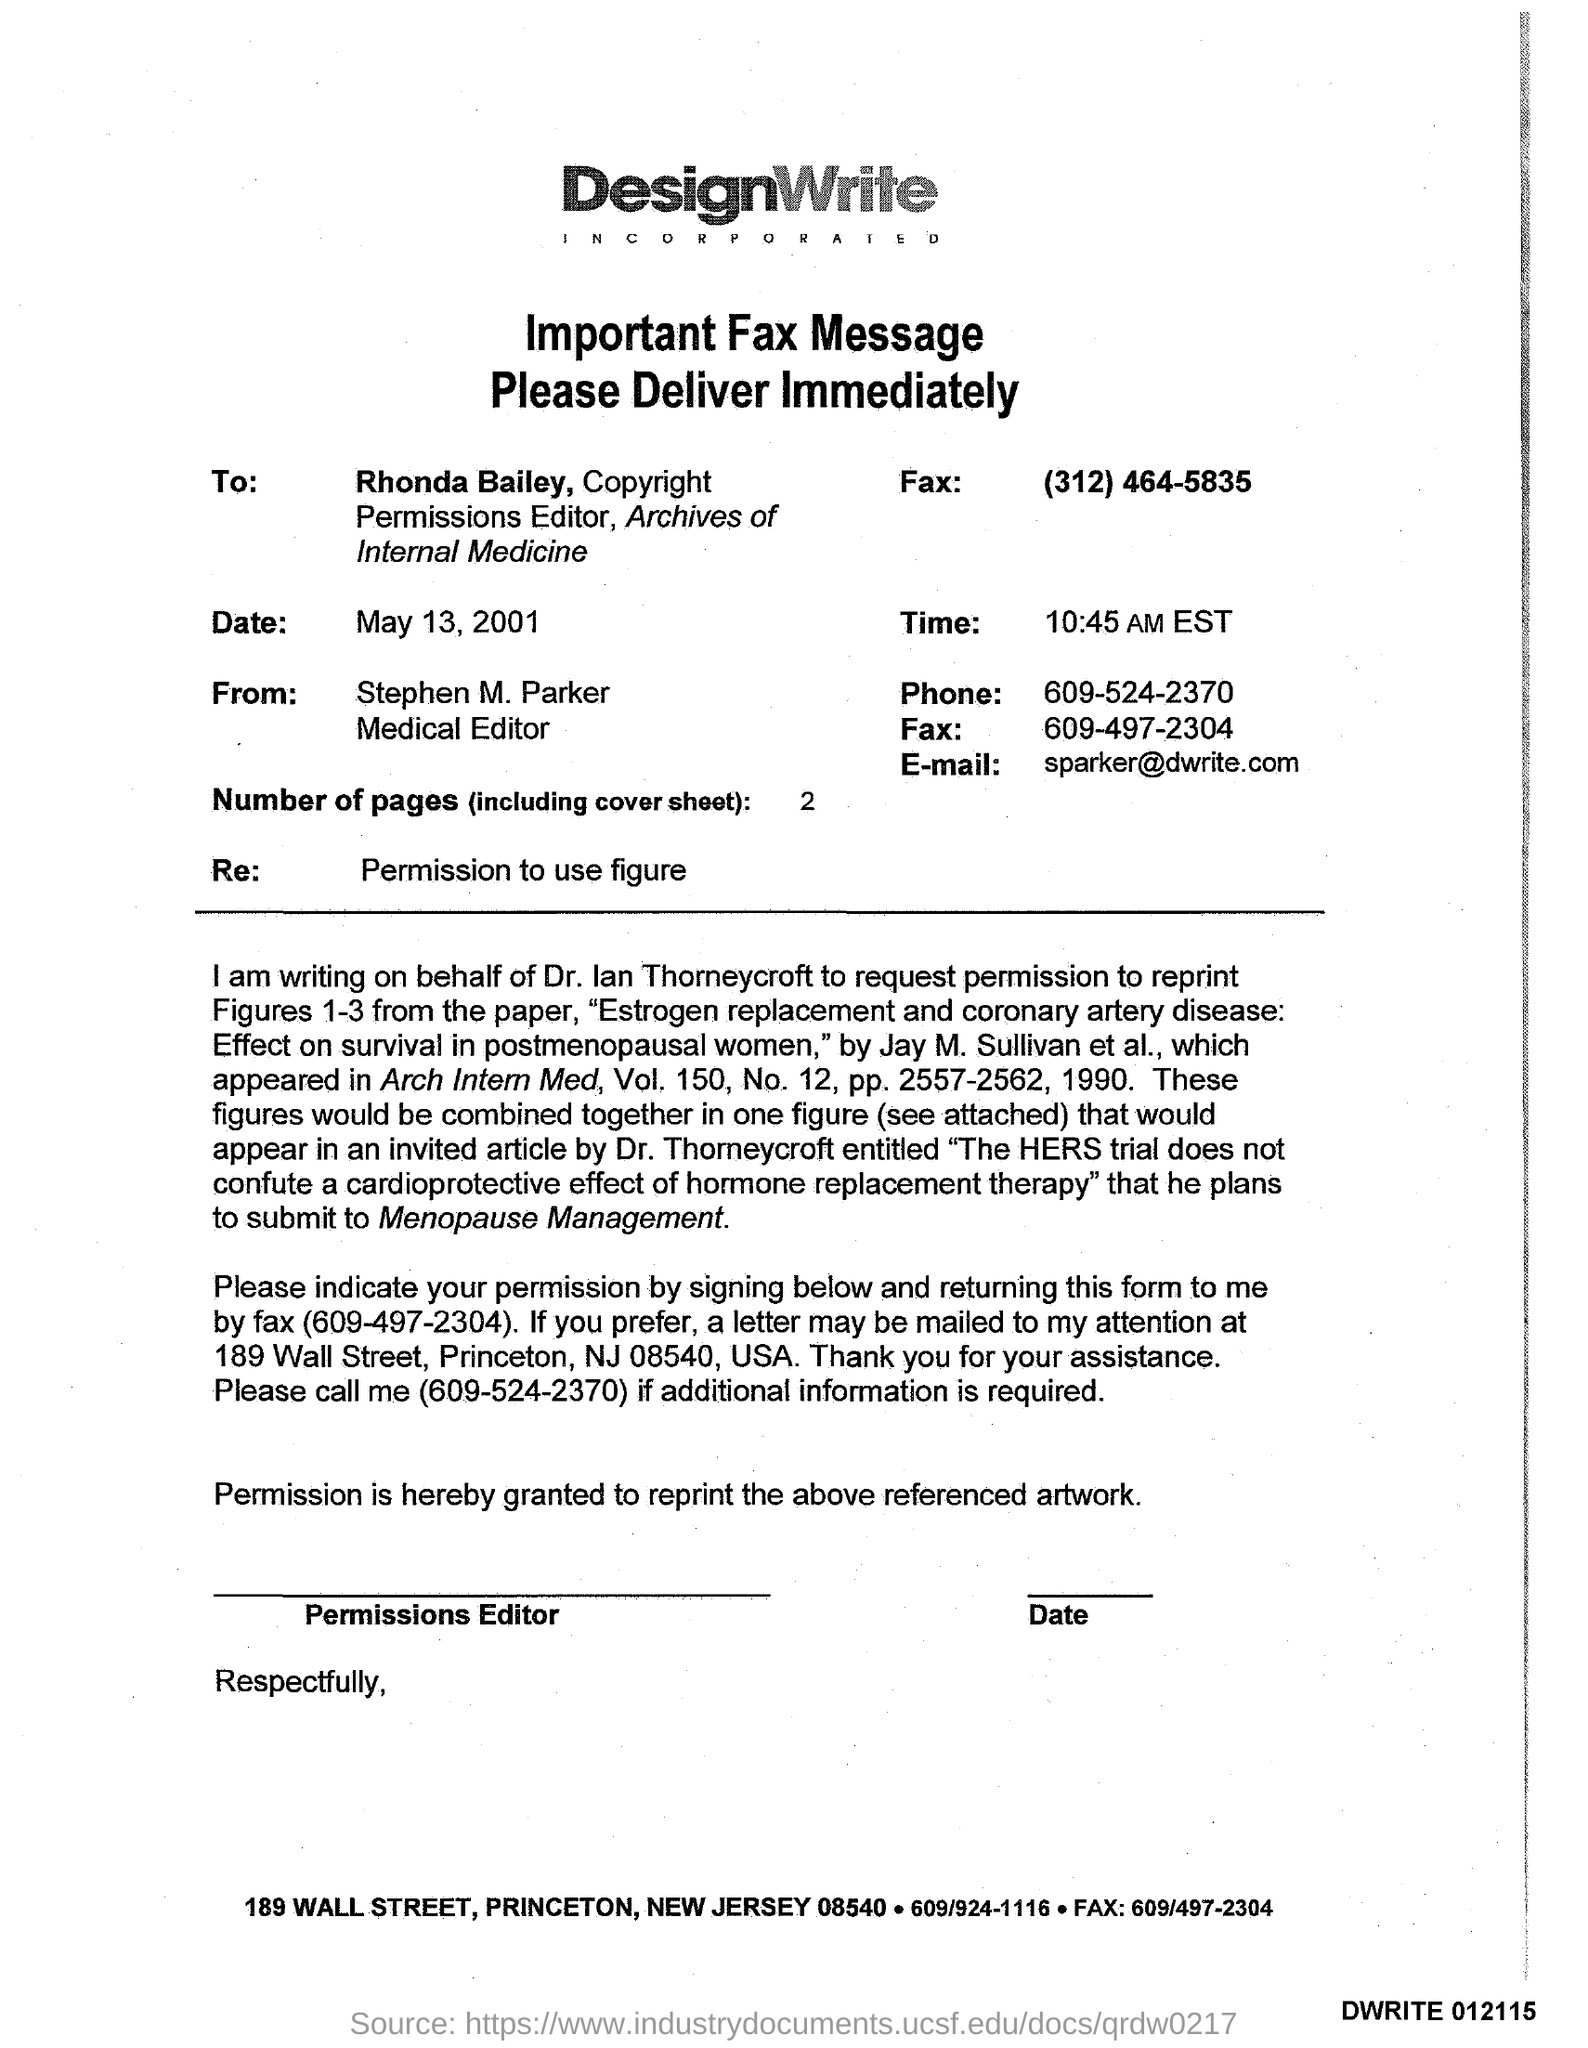Point out several critical features in this image. The fax number of Rhonda Bailey is (312) 464-5835. The date mentioned in the fax is May 13, 2001. Stephen M. Parker holds the designation of Medical Editor. The email address of Stephen M. Parker is [spark@dwrite.com](mailto:spark@dwrite.com). There are two pages in the fax, including the cover sheet. 